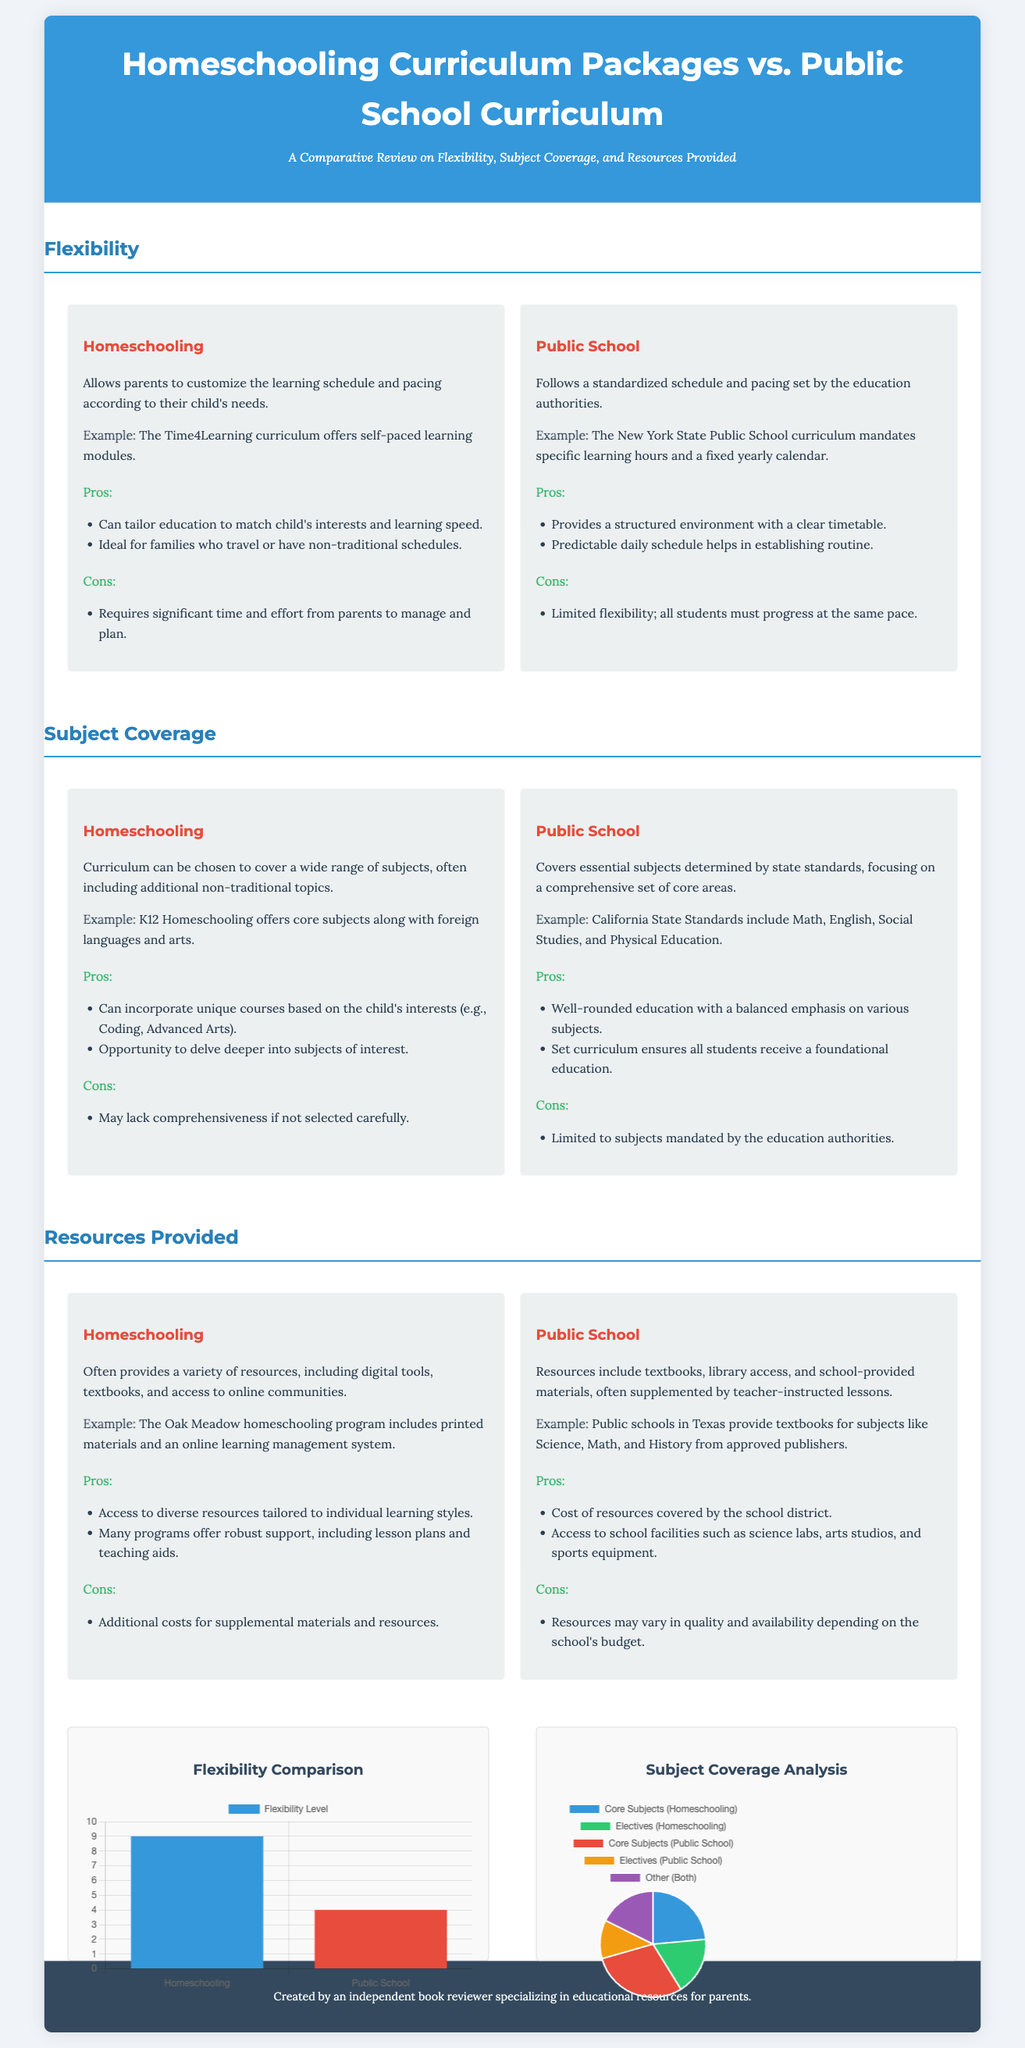What curriculum offers self-paced learning modules? The document states that Time4Learning offers self-paced learning modules as part of its homeschooling curriculum.
Answer: Time4Learning What is the flexibility level for homeschooling on the chart? According to the flexibility comparison chart in the document, the flexibility level for homeschooling is rated as 9.
Answer: 9 Which homeschooling program includes printed materials and an online learning management system? The document mentions that the Oak Meadow homeschooling program includes printed materials and an online learning management system.
Answer: Oak Meadow What percentage of core subjects is covered by public school according to the subject coverage chart? The subject coverage chart indicates that public schools cover 50% in core subjects.
Answer: 50% What are some unique courses that homeschooling can incorporate? The document lists coding and advanced arts as examples of unique courses that homeschooling can incorporate.
Answer: Coding, Advanced Arts What is the main disadvantage of public school flexibility? The document states that public school has limited flexibility, requiring all students to progress at the same pace.
Answer: Limited flexibility What type of chart compares flexibility levels? The document consists of a bar chart comparing flexibility levels for homeschooling and public school.
Answer: Bar chart What example is given for public school curriculum requirements? The document cites that the New York State Public School curriculum mandates specific learning hours and a fixed yearly calendar.
Answer: New York State Public School 